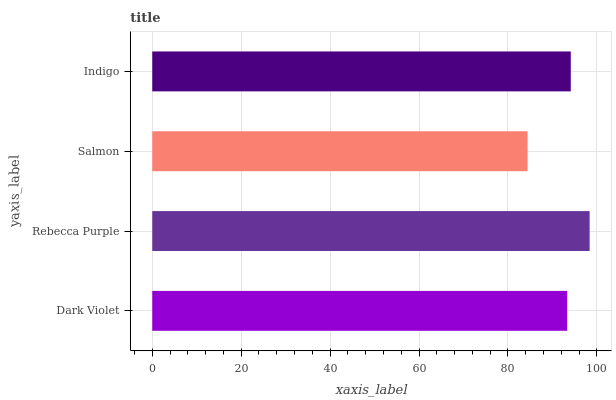Is Salmon the minimum?
Answer yes or no. Yes. Is Rebecca Purple the maximum?
Answer yes or no. Yes. Is Rebecca Purple the minimum?
Answer yes or no. No. Is Salmon the maximum?
Answer yes or no. No. Is Rebecca Purple greater than Salmon?
Answer yes or no. Yes. Is Salmon less than Rebecca Purple?
Answer yes or no. Yes. Is Salmon greater than Rebecca Purple?
Answer yes or no. No. Is Rebecca Purple less than Salmon?
Answer yes or no. No. Is Indigo the high median?
Answer yes or no. Yes. Is Dark Violet the low median?
Answer yes or no. Yes. Is Dark Violet the high median?
Answer yes or no. No. Is Indigo the low median?
Answer yes or no. No. 